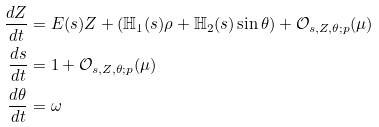Convert formula to latex. <formula><loc_0><loc_0><loc_500><loc_500>\frac { d Z } { d t } & = E ( s ) Z + ( { \mathbb { H } } _ { 1 } ( s ) \rho + { \mathbb { H } _ { 2 } } ( s ) \sin \theta ) + { \mathcal { O } } _ { s , Z , \theta ; p } ( \mu ) \\ \frac { d s } { d t } & = 1 + { \mathcal { O } } _ { s , Z , \theta ; p } ( \mu ) \\ \frac { d \theta } { d t } & = \omega</formula> 